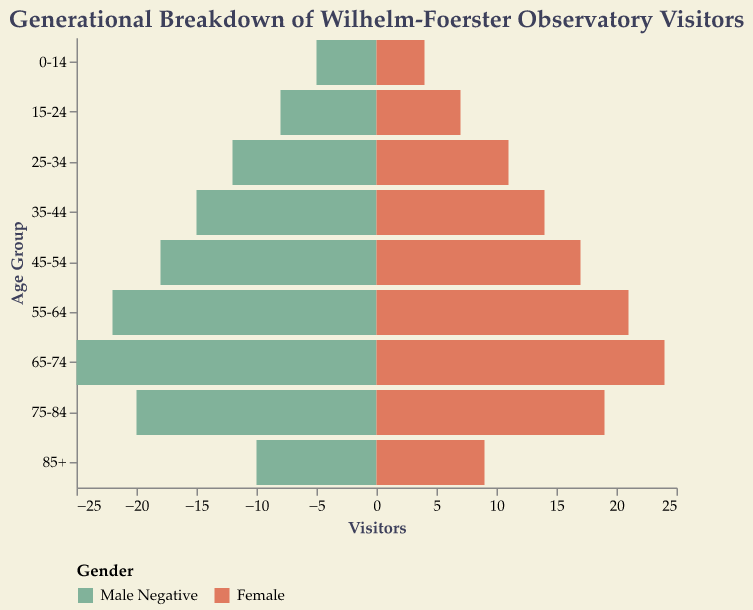What is the title of the figure? The title of the figure can be found at the top and it summarizes the content of the chart. It reads: "Generational Breakdown of Wilhelm-Foerster Observatory Visitors".
Answer: Generational Breakdown of Wilhelm-Foerster Observatory Visitors Which age group has the most male visitors? To determine this, look for the largest value among the "Male" bars. The largest male visitor count corresponds to the age group 65-74 with 25 male visitors.
Answer: 65-74 How many visitors are there in the age group 15-24 for both genders combined? For the age group 15-24, add the number of male visitors (8) and female visitors (7). So, the total is 8 + 7 = 15.
Answer: 15 Which gender has more visitors in the age group 55-64? Compare the values of the "Male" and "Female" bars for the age group 55-64. For males, there are 22 visitors, while for females, there are 21 visitors. Males have more visitors.
Answer: Male What is the sum of visitors in the age groups 45-54 and 35-44 for males? Add the number of male visitors in the 45-54 age group (18) and the 35-44 age group (15). So, the total is 18 + 15 = 33.
Answer: 33 Which age group has the least number of visitors? To find this, look for the age group with the smallest combined total of male and female visitors. The age group 0-14 has the least with 9 visitors (5 males + 4 females).
Answer: 0-14 Between which two consecutive age groups is there the largest increase in female visitors? Compare the increases in female visitors between each pair of consecutive age groups. The increase from age group 0-14 (4) to 15-24 (7) is 3, but the largest increase is from age group 75-84 (19) to 65-74 (24), which is 5.
Answer: 75-84 to 65-74 What is the difference in the number of visitors between the oldest age group (85+) and the youngest age group (0-14)? For the 85+ age group, there are 10 male and 9 female visitors, totaling 19. For the 0-14 age group, there are 5 male and 4 female visitors, totaling 9. The difference is 19 - 9 = 10.
Answer: 10 In which age group is the number of male visitors closest to the number of female visitors? Find the age group where the difference between male and female visitors is minimal. In the 0-14 age group, the difference is 1 (5 males - 4 females), which is the smallest difference.
Answer: 0-14 How many total visitors are there in the age group 75-84 for both genders? For the age group 75-84, add the number of male visitors (20) and female visitors (19). The total is 20 + 19 = 39.
Answer: 39 